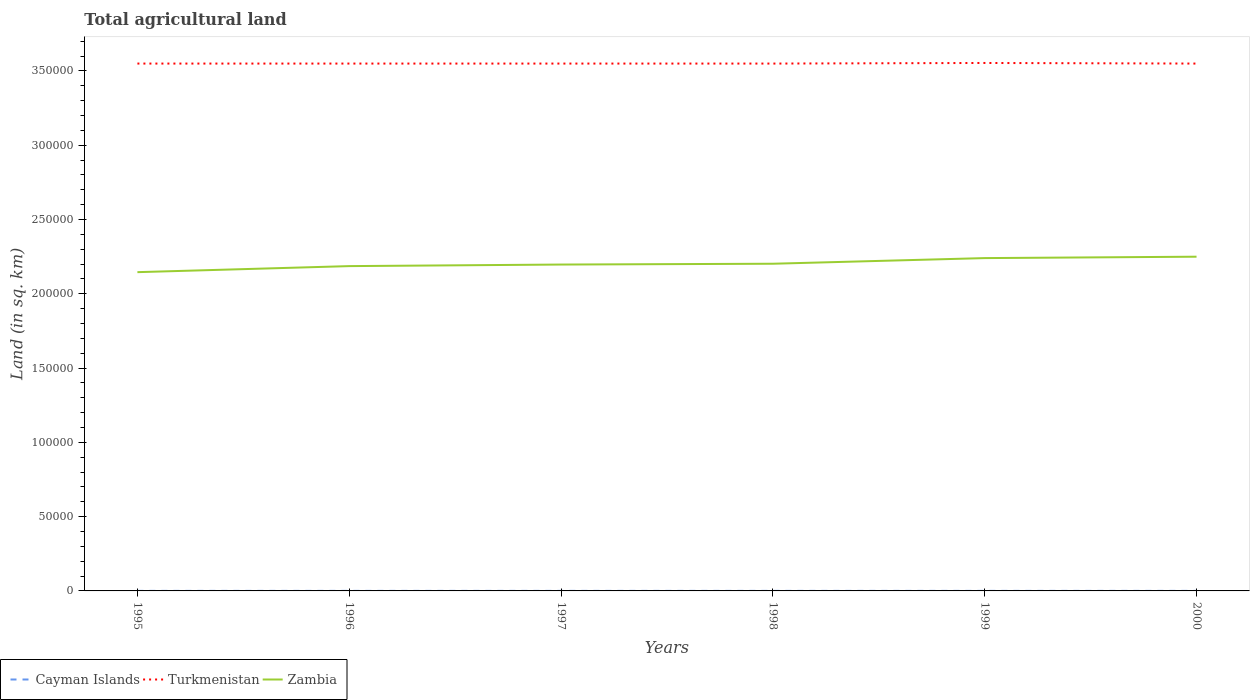How many different coloured lines are there?
Offer a very short reply. 3. Is the number of lines equal to the number of legend labels?
Provide a short and direct response. Yes. Across all years, what is the maximum total agricultural land in Zambia?
Your answer should be compact. 2.15e+05. In which year was the total agricultural land in Turkmenistan maximum?
Keep it short and to the point. 1995. What is the difference between the highest and the second highest total agricultural land in Zambia?
Your response must be concise. 1.04e+04. What is the difference between the highest and the lowest total agricultural land in Turkmenistan?
Keep it short and to the point. 1. Is the total agricultural land in Cayman Islands strictly greater than the total agricultural land in Zambia over the years?
Your answer should be very brief. Yes. How many lines are there?
Your answer should be compact. 3. Does the graph contain any zero values?
Provide a short and direct response. No. Where does the legend appear in the graph?
Offer a terse response. Bottom left. How many legend labels are there?
Your answer should be very brief. 3. What is the title of the graph?
Make the answer very short. Total agricultural land. Does "Brazil" appear as one of the legend labels in the graph?
Your response must be concise. No. What is the label or title of the Y-axis?
Your response must be concise. Land (in sq. km). What is the Land (in sq. km) in Turkmenistan in 1995?
Provide a short and direct response. 3.55e+05. What is the Land (in sq. km) of Zambia in 1995?
Your response must be concise. 2.15e+05. What is the Land (in sq. km) of Turkmenistan in 1996?
Offer a very short reply. 3.55e+05. What is the Land (in sq. km) in Zambia in 1996?
Offer a terse response. 2.19e+05. What is the Land (in sq. km) of Turkmenistan in 1997?
Make the answer very short. 3.55e+05. What is the Land (in sq. km) of Zambia in 1997?
Give a very brief answer. 2.20e+05. What is the Land (in sq. km) of Turkmenistan in 1998?
Ensure brevity in your answer.  3.55e+05. What is the Land (in sq. km) in Zambia in 1998?
Give a very brief answer. 2.20e+05. What is the Land (in sq. km) in Turkmenistan in 1999?
Provide a succinct answer. 3.55e+05. What is the Land (in sq. km) in Zambia in 1999?
Your answer should be very brief. 2.24e+05. What is the Land (in sq. km) in Cayman Islands in 2000?
Provide a succinct answer. 27. What is the Land (in sq. km) of Turkmenistan in 2000?
Your answer should be compact. 3.55e+05. What is the Land (in sq. km) of Zambia in 2000?
Provide a short and direct response. 2.25e+05. Across all years, what is the maximum Land (in sq. km) of Cayman Islands?
Offer a very short reply. 27. Across all years, what is the maximum Land (in sq. km) in Turkmenistan?
Provide a short and direct response. 3.55e+05. Across all years, what is the maximum Land (in sq. km) of Zambia?
Your answer should be compact. 2.25e+05. Across all years, what is the minimum Land (in sq. km) in Cayman Islands?
Offer a very short reply. 27. Across all years, what is the minimum Land (in sq. km) of Turkmenistan?
Your answer should be compact. 3.55e+05. Across all years, what is the minimum Land (in sq. km) in Zambia?
Provide a short and direct response. 2.15e+05. What is the total Land (in sq. km) in Cayman Islands in the graph?
Ensure brevity in your answer.  162. What is the total Land (in sq. km) in Turkmenistan in the graph?
Make the answer very short. 2.13e+06. What is the total Land (in sq. km) in Zambia in the graph?
Keep it short and to the point. 1.32e+06. What is the difference between the Land (in sq. km) of Cayman Islands in 1995 and that in 1996?
Offer a very short reply. 0. What is the difference between the Land (in sq. km) in Turkmenistan in 1995 and that in 1996?
Your answer should be very brief. 0. What is the difference between the Land (in sq. km) of Zambia in 1995 and that in 1996?
Your answer should be compact. -4070. What is the difference between the Land (in sq. km) of Zambia in 1995 and that in 1997?
Offer a very short reply. -5130. What is the difference between the Land (in sq. km) of Cayman Islands in 1995 and that in 1998?
Offer a very short reply. 0. What is the difference between the Land (in sq. km) of Zambia in 1995 and that in 1998?
Your response must be concise. -5670. What is the difference between the Land (in sq. km) in Turkmenistan in 1995 and that in 1999?
Provide a succinct answer. -400. What is the difference between the Land (in sq. km) in Zambia in 1995 and that in 1999?
Keep it short and to the point. -9470. What is the difference between the Land (in sq. km) of Zambia in 1995 and that in 2000?
Your response must be concise. -1.04e+04. What is the difference between the Land (in sq. km) in Turkmenistan in 1996 and that in 1997?
Offer a very short reply. 0. What is the difference between the Land (in sq. km) of Zambia in 1996 and that in 1997?
Ensure brevity in your answer.  -1060. What is the difference between the Land (in sq. km) of Cayman Islands in 1996 and that in 1998?
Provide a short and direct response. 0. What is the difference between the Land (in sq. km) in Zambia in 1996 and that in 1998?
Your answer should be very brief. -1600. What is the difference between the Land (in sq. km) of Turkmenistan in 1996 and that in 1999?
Offer a terse response. -400. What is the difference between the Land (in sq. km) in Zambia in 1996 and that in 1999?
Provide a short and direct response. -5400. What is the difference between the Land (in sq. km) of Zambia in 1996 and that in 2000?
Give a very brief answer. -6330. What is the difference between the Land (in sq. km) in Zambia in 1997 and that in 1998?
Your answer should be very brief. -540. What is the difference between the Land (in sq. km) in Turkmenistan in 1997 and that in 1999?
Keep it short and to the point. -400. What is the difference between the Land (in sq. km) in Zambia in 1997 and that in 1999?
Your answer should be very brief. -4340. What is the difference between the Land (in sq. km) of Zambia in 1997 and that in 2000?
Offer a terse response. -5270. What is the difference between the Land (in sq. km) of Turkmenistan in 1998 and that in 1999?
Keep it short and to the point. -400. What is the difference between the Land (in sq. km) in Zambia in 1998 and that in 1999?
Your answer should be very brief. -3800. What is the difference between the Land (in sq. km) of Cayman Islands in 1998 and that in 2000?
Provide a succinct answer. 0. What is the difference between the Land (in sq. km) in Turkmenistan in 1998 and that in 2000?
Ensure brevity in your answer.  0. What is the difference between the Land (in sq. km) in Zambia in 1998 and that in 2000?
Keep it short and to the point. -4730. What is the difference between the Land (in sq. km) of Zambia in 1999 and that in 2000?
Provide a short and direct response. -930. What is the difference between the Land (in sq. km) of Cayman Islands in 1995 and the Land (in sq. km) of Turkmenistan in 1996?
Offer a terse response. -3.55e+05. What is the difference between the Land (in sq. km) of Cayman Islands in 1995 and the Land (in sq. km) of Zambia in 1996?
Offer a very short reply. -2.19e+05. What is the difference between the Land (in sq. km) of Turkmenistan in 1995 and the Land (in sq. km) of Zambia in 1996?
Your response must be concise. 1.36e+05. What is the difference between the Land (in sq. km) of Cayman Islands in 1995 and the Land (in sq. km) of Turkmenistan in 1997?
Make the answer very short. -3.55e+05. What is the difference between the Land (in sq. km) in Cayman Islands in 1995 and the Land (in sq. km) in Zambia in 1997?
Your response must be concise. -2.20e+05. What is the difference between the Land (in sq. km) of Turkmenistan in 1995 and the Land (in sq. km) of Zambia in 1997?
Your answer should be compact. 1.35e+05. What is the difference between the Land (in sq. km) of Cayman Islands in 1995 and the Land (in sq. km) of Turkmenistan in 1998?
Provide a short and direct response. -3.55e+05. What is the difference between the Land (in sq. km) in Cayman Islands in 1995 and the Land (in sq. km) in Zambia in 1998?
Offer a terse response. -2.20e+05. What is the difference between the Land (in sq. km) in Turkmenistan in 1995 and the Land (in sq. km) in Zambia in 1998?
Provide a short and direct response. 1.35e+05. What is the difference between the Land (in sq. km) of Cayman Islands in 1995 and the Land (in sq. km) of Turkmenistan in 1999?
Keep it short and to the point. -3.55e+05. What is the difference between the Land (in sq. km) of Cayman Islands in 1995 and the Land (in sq. km) of Zambia in 1999?
Your answer should be compact. -2.24e+05. What is the difference between the Land (in sq. km) of Turkmenistan in 1995 and the Land (in sq. km) of Zambia in 1999?
Provide a succinct answer. 1.31e+05. What is the difference between the Land (in sq. km) in Cayman Islands in 1995 and the Land (in sq. km) in Turkmenistan in 2000?
Give a very brief answer. -3.55e+05. What is the difference between the Land (in sq. km) of Cayman Islands in 1995 and the Land (in sq. km) of Zambia in 2000?
Provide a short and direct response. -2.25e+05. What is the difference between the Land (in sq. km) of Turkmenistan in 1995 and the Land (in sq. km) of Zambia in 2000?
Make the answer very short. 1.30e+05. What is the difference between the Land (in sq. km) in Cayman Islands in 1996 and the Land (in sq. km) in Turkmenistan in 1997?
Your answer should be compact. -3.55e+05. What is the difference between the Land (in sq. km) of Cayman Islands in 1996 and the Land (in sq. km) of Zambia in 1997?
Make the answer very short. -2.20e+05. What is the difference between the Land (in sq. km) of Turkmenistan in 1996 and the Land (in sq. km) of Zambia in 1997?
Give a very brief answer. 1.35e+05. What is the difference between the Land (in sq. km) of Cayman Islands in 1996 and the Land (in sq. km) of Turkmenistan in 1998?
Offer a very short reply. -3.55e+05. What is the difference between the Land (in sq. km) of Cayman Islands in 1996 and the Land (in sq. km) of Zambia in 1998?
Make the answer very short. -2.20e+05. What is the difference between the Land (in sq. km) in Turkmenistan in 1996 and the Land (in sq. km) in Zambia in 1998?
Your answer should be compact. 1.35e+05. What is the difference between the Land (in sq. km) of Cayman Islands in 1996 and the Land (in sq. km) of Turkmenistan in 1999?
Make the answer very short. -3.55e+05. What is the difference between the Land (in sq. km) of Cayman Islands in 1996 and the Land (in sq. km) of Zambia in 1999?
Provide a short and direct response. -2.24e+05. What is the difference between the Land (in sq. km) of Turkmenistan in 1996 and the Land (in sq. km) of Zambia in 1999?
Your answer should be compact. 1.31e+05. What is the difference between the Land (in sq. km) of Cayman Islands in 1996 and the Land (in sq. km) of Turkmenistan in 2000?
Your answer should be very brief. -3.55e+05. What is the difference between the Land (in sq. km) in Cayman Islands in 1996 and the Land (in sq. km) in Zambia in 2000?
Make the answer very short. -2.25e+05. What is the difference between the Land (in sq. km) of Turkmenistan in 1996 and the Land (in sq. km) of Zambia in 2000?
Provide a short and direct response. 1.30e+05. What is the difference between the Land (in sq. km) in Cayman Islands in 1997 and the Land (in sq. km) in Turkmenistan in 1998?
Your answer should be very brief. -3.55e+05. What is the difference between the Land (in sq. km) in Cayman Islands in 1997 and the Land (in sq. km) in Zambia in 1998?
Your answer should be compact. -2.20e+05. What is the difference between the Land (in sq. km) of Turkmenistan in 1997 and the Land (in sq. km) of Zambia in 1998?
Offer a very short reply. 1.35e+05. What is the difference between the Land (in sq. km) in Cayman Islands in 1997 and the Land (in sq. km) in Turkmenistan in 1999?
Provide a succinct answer. -3.55e+05. What is the difference between the Land (in sq. km) of Cayman Islands in 1997 and the Land (in sq. km) of Zambia in 1999?
Your response must be concise. -2.24e+05. What is the difference between the Land (in sq. km) of Turkmenistan in 1997 and the Land (in sq. km) of Zambia in 1999?
Make the answer very short. 1.31e+05. What is the difference between the Land (in sq. km) in Cayman Islands in 1997 and the Land (in sq. km) in Turkmenistan in 2000?
Make the answer very short. -3.55e+05. What is the difference between the Land (in sq. km) of Cayman Islands in 1997 and the Land (in sq. km) of Zambia in 2000?
Make the answer very short. -2.25e+05. What is the difference between the Land (in sq. km) of Turkmenistan in 1997 and the Land (in sq. km) of Zambia in 2000?
Your answer should be very brief. 1.30e+05. What is the difference between the Land (in sq. km) in Cayman Islands in 1998 and the Land (in sq. km) in Turkmenistan in 1999?
Make the answer very short. -3.55e+05. What is the difference between the Land (in sq. km) in Cayman Islands in 1998 and the Land (in sq. km) in Zambia in 1999?
Your answer should be compact. -2.24e+05. What is the difference between the Land (in sq. km) of Turkmenistan in 1998 and the Land (in sq. km) of Zambia in 1999?
Keep it short and to the point. 1.31e+05. What is the difference between the Land (in sq. km) in Cayman Islands in 1998 and the Land (in sq. km) in Turkmenistan in 2000?
Make the answer very short. -3.55e+05. What is the difference between the Land (in sq. km) in Cayman Islands in 1998 and the Land (in sq. km) in Zambia in 2000?
Provide a short and direct response. -2.25e+05. What is the difference between the Land (in sq. km) in Turkmenistan in 1998 and the Land (in sq. km) in Zambia in 2000?
Make the answer very short. 1.30e+05. What is the difference between the Land (in sq. km) in Cayman Islands in 1999 and the Land (in sq. km) in Turkmenistan in 2000?
Offer a terse response. -3.55e+05. What is the difference between the Land (in sq. km) of Cayman Islands in 1999 and the Land (in sq. km) of Zambia in 2000?
Provide a succinct answer. -2.25e+05. What is the difference between the Land (in sq. km) of Turkmenistan in 1999 and the Land (in sq. km) of Zambia in 2000?
Give a very brief answer. 1.30e+05. What is the average Land (in sq. km) of Turkmenistan per year?
Keep it short and to the point. 3.55e+05. What is the average Land (in sq. km) in Zambia per year?
Your answer should be compact. 2.20e+05. In the year 1995, what is the difference between the Land (in sq. km) in Cayman Islands and Land (in sq. km) in Turkmenistan?
Offer a very short reply. -3.55e+05. In the year 1995, what is the difference between the Land (in sq. km) of Cayman Islands and Land (in sq. km) of Zambia?
Give a very brief answer. -2.15e+05. In the year 1995, what is the difference between the Land (in sq. km) of Turkmenistan and Land (in sq. km) of Zambia?
Provide a succinct answer. 1.40e+05. In the year 1996, what is the difference between the Land (in sq. km) in Cayman Islands and Land (in sq. km) in Turkmenistan?
Offer a terse response. -3.55e+05. In the year 1996, what is the difference between the Land (in sq. km) in Cayman Islands and Land (in sq. km) in Zambia?
Make the answer very short. -2.19e+05. In the year 1996, what is the difference between the Land (in sq. km) of Turkmenistan and Land (in sq. km) of Zambia?
Keep it short and to the point. 1.36e+05. In the year 1997, what is the difference between the Land (in sq. km) of Cayman Islands and Land (in sq. km) of Turkmenistan?
Offer a terse response. -3.55e+05. In the year 1997, what is the difference between the Land (in sq. km) of Cayman Islands and Land (in sq. km) of Zambia?
Provide a succinct answer. -2.20e+05. In the year 1997, what is the difference between the Land (in sq. km) of Turkmenistan and Land (in sq. km) of Zambia?
Give a very brief answer. 1.35e+05. In the year 1998, what is the difference between the Land (in sq. km) in Cayman Islands and Land (in sq. km) in Turkmenistan?
Give a very brief answer. -3.55e+05. In the year 1998, what is the difference between the Land (in sq. km) of Cayman Islands and Land (in sq. km) of Zambia?
Provide a short and direct response. -2.20e+05. In the year 1998, what is the difference between the Land (in sq. km) of Turkmenistan and Land (in sq. km) of Zambia?
Offer a very short reply. 1.35e+05. In the year 1999, what is the difference between the Land (in sq. km) of Cayman Islands and Land (in sq. km) of Turkmenistan?
Your answer should be compact. -3.55e+05. In the year 1999, what is the difference between the Land (in sq. km) in Cayman Islands and Land (in sq. km) in Zambia?
Give a very brief answer. -2.24e+05. In the year 1999, what is the difference between the Land (in sq. km) in Turkmenistan and Land (in sq. km) in Zambia?
Make the answer very short. 1.31e+05. In the year 2000, what is the difference between the Land (in sq. km) in Cayman Islands and Land (in sq. km) in Turkmenistan?
Your response must be concise. -3.55e+05. In the year 2000, what is the difference between the Land (in sq. km) in Cayman Islands and Land (in sq. km) in Zambia?
Ensure brevity in your answer.  -2.25e+05. In the year 2000, what is the difference between the Land (in sq. km) of Turkmenistan and Land (in sq. km) of Zambia?
Give a very brief answer. 1.30e+05. What is the ratio of the Land (in sq. km) in Cayman Islands in 1995 to that in 1996?
Offer a terse response. 1. What is the ratio of the Land (in sq. km) of Zambia in 1995 to that in 1996?
Your answer should be very brief. 0.98. What is the ratio of the Land (in sq. km) of Cayman Islands in 1995 to that in 1997?
Your response must be concise. 1. What is the ratio of the Land (in sq. km) of Turkmenistan in 1995 to that in 1997?
Ensure brevity in your answer.  1. What is the ratio of the Land (in sq. km) of Zambia in 1995 to that in 1997?
Your answer should be very brief. 0.98. What is the ratio of the Land (in sq. km) of Cayman Islands in 1995 to that in 1998?
Give a very brief answer. 1. What is the ratio of the Land (in sq. km) of Turkmenistan in 1995 to that in 1998?
Make the answer very short. 1. What is the ratio of the Land (in sq. km) in Zambia in 1995 to that in 1998?
Provide a succinct answer. 0.97. What is the ratio of the Land (in sq. km) of Cayman Islands in 1995 to that in 1999?
Provide a short and direct response. 1. What is the ratio of the Land (in sq. km) in Turkmenistan in 1995 to that in 1999?
Give a very brief answer. 1. What is the ratio of the Land (in sq. km) in Zambia in 1995 to that in 1999?
Provide a succinct answer. 0.96. What is the ratio of the Land (in sq. km) of Zambia in 1995 to that in 2000?
Ensure brevity in your answer.  0.95. What is the ratio of the Land (in sq. km) of Cayman Islands in 1996 to that in 1997?
Offer a very short reply. 1. What is the ratio of the Land (in sq. km) in Zambia in 1996 to that in 1997?
Make the answer very short. 1. What is the ratio of the Land (in sq. km) of Cayman Islands in 1996 to that in 1998?
Make the answer very short. 1. What is the ratio of the Land (in sq. km) of Cayman Islands in 1996 to that in 1999?
Your answer should be very brief. 1. What is the ratio of the Land (in sq. km) in Turkmenistan in 1996 to that in 1999?
Your answer should be compact. 1. What is the ratio of the Land (in sq. km) in Zambia in 1996 to that in 1999?
Offer a very short reply. 0.98. What is the ratio of the Land (in sq. km) of Zambia in 1996 to that in 2000?
Offer a very short reply. 0.97. What is the ratio of the Land (in sq. km) in Zambia in 1997 to that in 1998?
Offer a very short reply. 1. What is the ratio of the Land (in sq. km) in Zambia in 1997 to that in 1999?
Keep it short and to the point. 0.98. What is the ratio of the Land (in sq. km) of Cayman Islands in 1997 to that in 2000?
Provide a short and direct response. 1. What is the ratio of the Land (in sq. km) of Turkmenistan in 1997 to that in 2000?
Ensure brevity in your answer.  1. What is the ratio of the Land (in sq. km) of Zambia in 1997 to that in 2000?
Offer a very short reply. 0.98. What is the ratio of the Land (in sq. km) of Turkmenistan in 1998 to that in 1999?
Your response must be concise. 1. What is the ratio of the Land (in sq. km) of Turkmenistan in 1998 to that in 2000?
Give a very brief answer. 1. What is the ratio of the Land (in sq. km) in Cayman Islands in 1999 to that in 2000?
Your response must be concise. 1. What is the ratio of the Land (in sq. km) of Turkmenistan in 1999 to that in 2000?
Offer a very short reply. 1. What is the ratio of the Land (in sq. km) in Zambia in 1999 to that in 2000?
Give a very brief answer. 1. What is the difference between the highest and the second highest Land (in sq. km) in Zambia?
Offer a very short reply. 930. What is the difference between the highest and the lowest Land (in sq. km) of Cayman Islands?
Your answer should be compact. 0. What is the difference between the highest and the lowest Land (in sq. km) of Zambia?
Your response must be concise. 1.04e+04. 